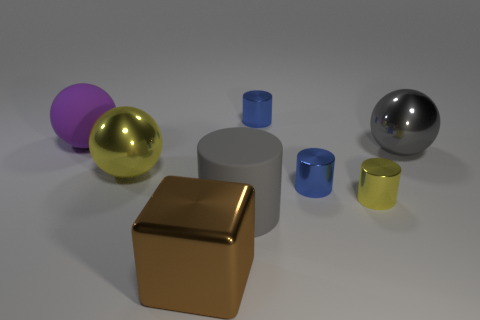Subtract all large gray cylinders. How many cylinders are left? 3 Subtract all yellow cylinders. How many cylinders are left? 3 Subtract all cyan cylinders. Subtract all red blocks. How many cylinders are left? 4 Add 2 large rubber spheres. How many objects exist? 10 Subtract all spheres. How many objects are left? 5 Subtract 0 blue balls. How many objects are left? 8 Subtract all gray metal balls. Subtract all small purple cubes. How many objects are left? 7 Add 1 blue metal things. How many blue metal things are left? 3 Add 2 purple spheres. How many purple spheres exist? 3 